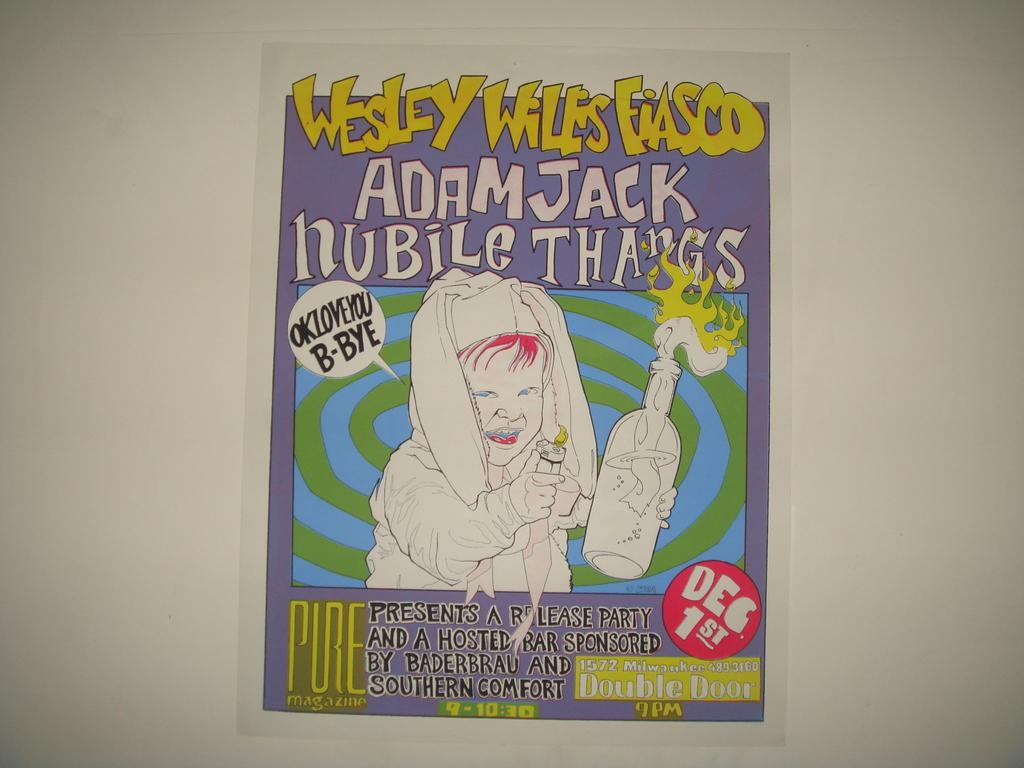Provide a one-sentence caption for the provided image. Invitation for dec. 1st for a release party, there is a bar included. 